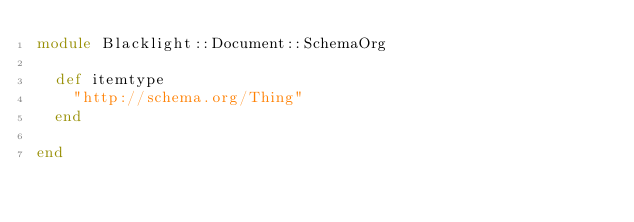<code> <loc_0><loc_0><loc_500><loc_500><_Ruby_>module Blacklight::Document::SchemaOrg

  def itemtype
    "http://schema.org/Thing"
  end

end
</code> 